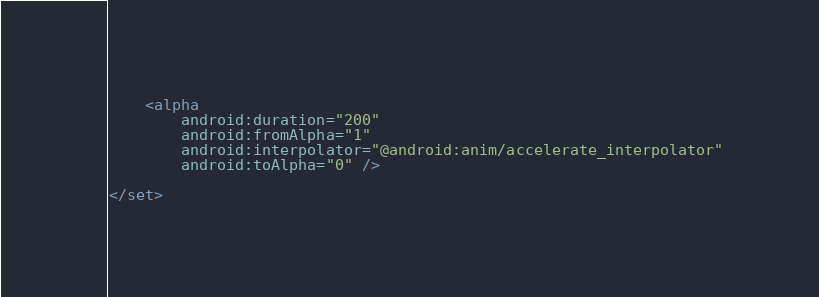Convert code to text. <code><loc_0><loc_0><loc_500><loc_500><_XML_>
    <alpha
        android:duration="200"
        android:fromAlpha="1"
        android:interpolator="@android:anim/accelerate_interpolator"
        android:toAlpha="0" />

</set></code> 